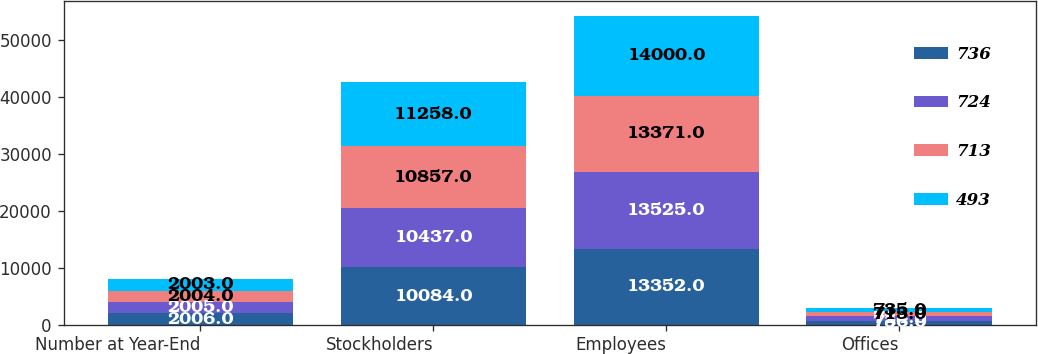<chart> <loc_0><loc_0><loc_500><loc_500><stacked_bar_chart><ecel><fcel>Number at Year-End<fcel>Stockholders<fcel>Employees<fcel>Offices<nl><fcel>736<fcel>2006<fcel>10084<fcel>13352<fcel>736<nl><fcel>724<fcel>2005<fcel>10437<fcel>13525<fcel>724<nl><fcel>713<fcel>2004<fcel>10857<fcel>13371<fcel>713<nl><fcel>493<fcel>2003<fcel>11258<fcel>14000<fcel>735<nl></chart> 